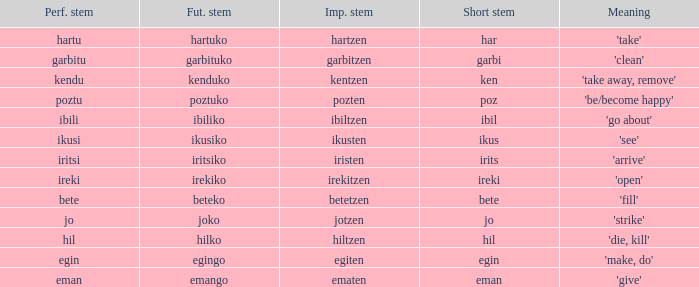What is the perfect stem for pozten? Poztu. 